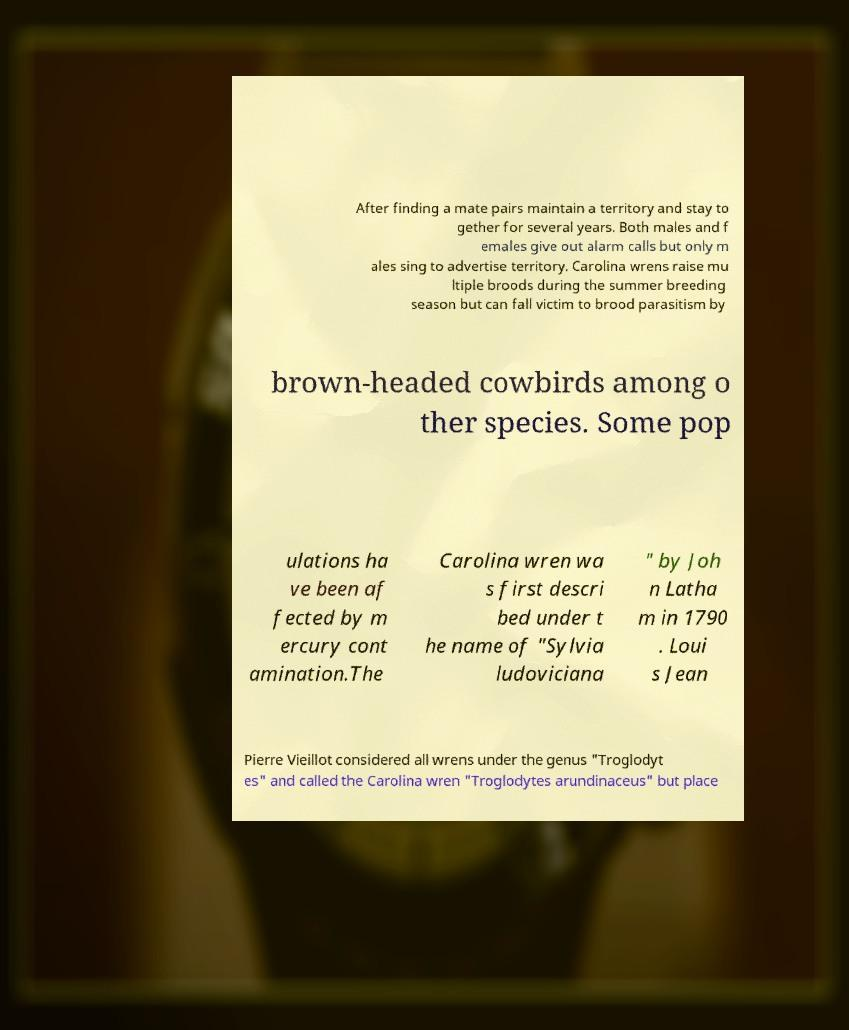What messages or text are displayed in this image? I need them in a readable, typed format. After finding a mate pairs maintain a territory and stay to gether for several years. Both males and f emales give out alarm calls but only m ales sing to advertise territory. Carolina wrens raise mu ltiple broods during the summer breeding season but can fall victim to brood parasitism by brown-headed cowbirds among o ther species. Some pop ulations ha ve been af fected by m ercury cont amination.The Carolina wren wa s first descri bed under t he name of "Sylvia ludoviciana " by Joh n Latha m in 1790 . Loui s Jean Pierre Vieillot considered all wrens under the genus "Troglodyt es" and called the Carolina wren "Troglodytes arundinaceus" but place 